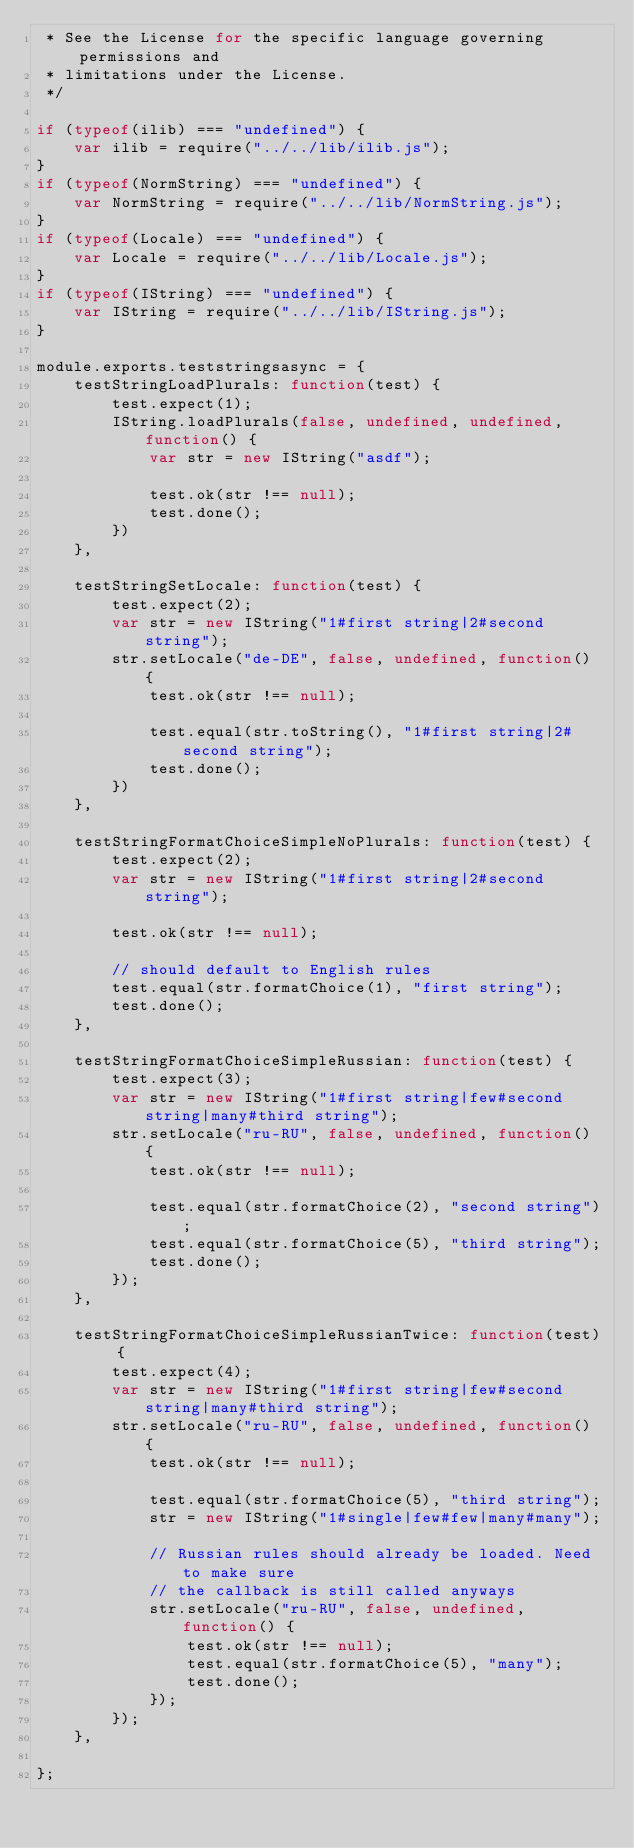Convert code to text. <code><loc_0><loc_0><loc_500><loc_500><_JavaScript_> * See the License for the specific language governing permissions and
 * limitations under the License.
 */

if (typeof(ilib) === "undefined") {
    var ilib = require("../../lib/ilib.js");
}
if (typeof(NormString) === "undefined") {
    var NormString = require("../../lib/NormString.js");
}
if (typeof(Locale) === "undefined") {
    var Locale = require("../../lib/Locale.js");
}
if (typeof(IString) === "undefined") {
    var IString = require("../../lib/IString.js");
}

module.exports.teststringsasync = {
    testStringLoadPlurals: function(test) {
        test.expect(1);
        IString.loadPlurals(false, undefined, undefined, function() {
            var str = new IString("asdf");

            test.ok(str !== null);
            test.done();
        })
    },

    testStringSetLocale: function(test) {
        test.expect(2);
        var str = new IString("1#first string|2#second string");
        str.setLocale("de-DE", false, undefined, function() {
            test.ok(str !== null);

            test.equal(str.toString(), "1#first string|2#second string");
            test.done();
        })
    },

    testStringFormatChoiceSimpleNoPlurals: function(test) {
        test.expect(2);
        var str = new IString("1#first string|2#second string");

        test.ok(str !== null);

        // should default to English rules
        test.equal(str.formatChoice(1), "first string");
        test.done();
    },

    testStringFormatChoiceSimpleRussian: function(test) {
        test.expect(3);
        var str = new IString("1#first string|few#second string|many#third string");
        str.setLocale("ru-RU", false, undefined, function() {
            test.ok(str !== null);

            test.equal(str.formatChoice(2), "second string");
            test.equal(str.formatChoice(5), "third string");
            test.done();
        });
    },

    testStringFormatChoiceSimpleRussianTwice: function(test) {
        test.expect(4);
        var str = new IString("1#first string|few#second string|many#third string");
        str.setLocale("ru-RU", false, undefined, function() {
            test.ok(str !== null);

            test.equal(str.formatChoice(5), "third string");
            str = new IString("1#single|few#few|many#many");

            // Russian rules should already be loaded. Need to make sure
            // the callback is still called anyways
            str.setLocale("ru-RU", false, undefined, function() {
                test.ok(str !== null);
                test.equal(str.formatChoice(5), "many");
                test.done();
            });
        });
    },

};
</code> 